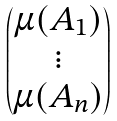<formula> <loc_0><loc_0><loc_500><loc_500>\begin{pmatrix} \mu ( A _ { 1 } ) \\ \vdots \\ \mu ( A _ { n } ) \end{pmatrix}</formula> 